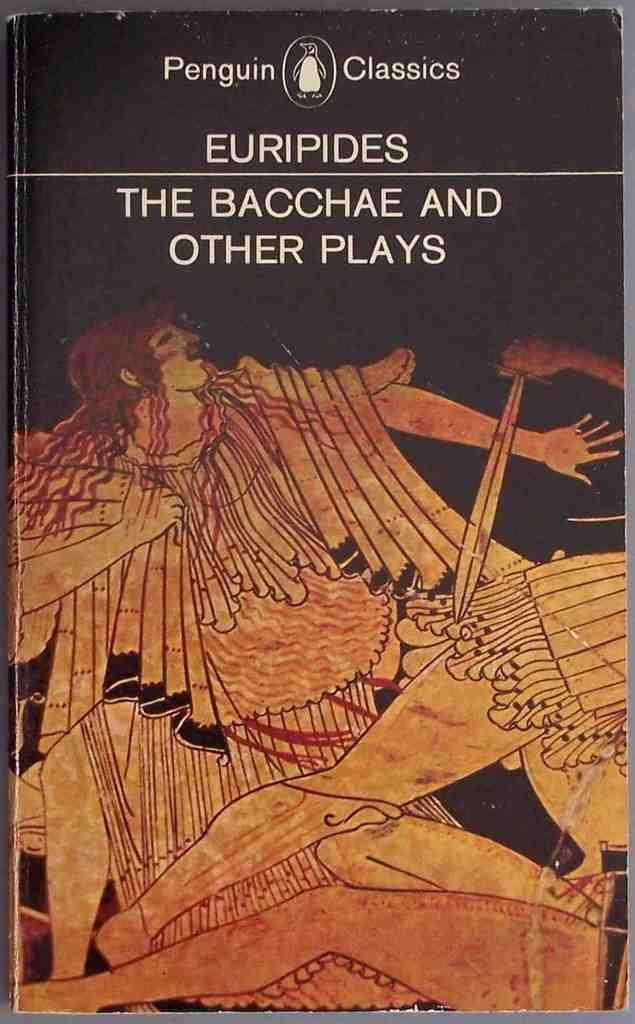What is the main object in the image? There is a book in the image. What type of content does the book have? The book has pictures and text. Can you describe the painting on the book? The painting on the book depicts humans. What is written on the book? There is text on top of the book. Can you describe the fight scene depicted in the painting on the book? There is no fight scene depicted in the painting on the book; it features humans without any indication of a fight. 